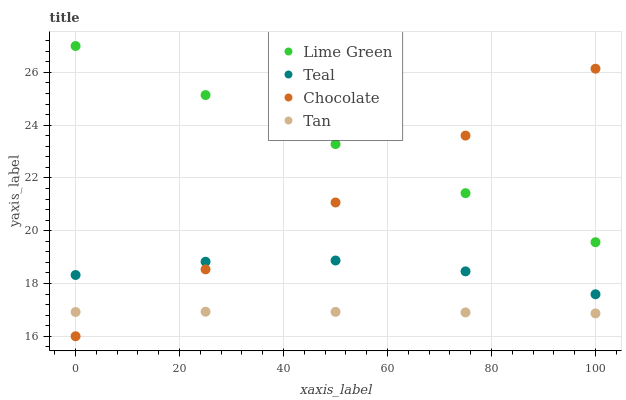Does Tan have the minimum area under the curve?
Answer yes or no. Yes. Does Lime Green have the maximum area under the curve?
Answer yes or no. Yes. Does Teal have the minimum area under the curve?
Answer yes or no. No. Does Teal have the maximum area under the curve?
Answer yes or no. No. Is Lime Green the smoothest?
Answer yes or no. Yes. Is Teal the roughest?
Answer yes or no. Yes. Is Teal the smoothest?
Answer yes or no. No. Is Lime Green the roughest?
Answer yes or no. No. Does Chocolate have the lowest value?
Answer yes or no. Yes. Does Teal have the lowest value?
Answer yes or no. No. Does Lime Green have the highest value?
Answer yes or no. Yes. Does Teal have the highest value?
Answer yes or no. No. Is Tan less than Lime Green?
Answer yes or no. Yes. Is Lime Green greater than Teal?
Answer yes or no. Yes. Does Teal intersect Chocolate?
Answer yes or no. Yes. Is Teal less than Chocolate?
Answer yes or no. No. Is Teal greater than Chocolate?
Answer yes or no. No. Does Tan intersect Lime Green?
Answer yes or no. No. 